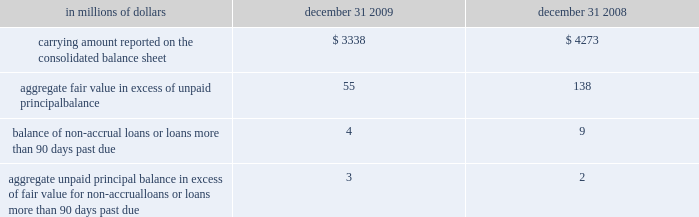Certain mortgage loans citigroup has elected the fair value option for certain purchased and originated prime fixed-rate and conforming adjustable-rate first mortgage loans held-for-sale .
These loans are intended for sale or securitization and are hedged with derivative instruments .
The company has elected the fair value option to mitigate accounting mismatches in cases where hedge .
The changes in fair values of these mortgage loans are reported in other revenue in the company 2019s consolidated statement of income .
The changes in fair value during the years ended december 31 , 2009 and 2008 due to instrument-specific credit risk resulted in a $ 10 million loss and $ 32 million loss , respectively .
Related interest income continues to be measured based on the contractual interest rates and reported as such in the consolidated statement of income .
Mortgage servicing rights the company accounts for mortgage servicing rights ( msrs ) at fair value .
Fair value for msrs is determined using an option-adjusted spread valuation approach .
This approach consists of projecting servicing cash flows under multiple interest-rate scenarios and discounting these cash flows using risk-adjusted rates .
The model assumptions used in the valuation of msrs include mortgage prepayment speeds and discount rates .
The fair value of msrs is primarily affected by changes in prepayments that result from shifts in mortgage interest rates .
In managing this risk , the company hedges a significant portion of the values of its msrs through the use of interest-rate derivative contracts , forward-purchase commitments of mortgage-backed securities , and purchased securities classified as trading .
See note 23 to the consolidated financial statements for further discussions regarding the accounting and reporting of msrs .
These msrs , which totaled $ 6.5 billion and $ 5.7 billion as of december 31 , 2009 and 2008 , respectively , are classified as mortgage servicing rights on citigroup 2019s consolidated balance sheet .
Changes in fair value of msrs are recorded in commissions and fees in the company 2019s consolidated statement of income .
Certain structured liabilities the company has elected the fair value option for certain structured liabilities whose performance is linked to structured interest rates , inflation or currency risks ( 201cstructured liabilities 201d ) .
The company elected the fair value option , because these exposures are considered to be trading-related positions and , therefore , are managed on a fair value basis .
These positions will continue to be classified as debt , deposits or derivatives ( trading account liabilities ) on the company 2019s consolidated balance sheet according to their legal form .
For those structured liabilities classified as long-term debt for which the fair value option has been elected , the aggregate unpaid principal balance exceeded the aggregate fair value by $ 125 million and $ 671 million as of december 31 , 2009 and 2008 , respectively .
The change in fair value for these structured liabilities is reported in principal transactions in the company 2019s consolidated statement of income .
Related interest expense is measured based on the contractual interest rates and reported as such in the consolidated income statement .
Certain non-structured liabilities the company has elected the fair value option for certain non-structured liabilities with fixed and floating interest rates ( 201cnon-structured liabilities 201d ) .
The company has elected the fair value option where the interest-rate risk of such liabilities is economically hedged with derivative contracts or the proceeds are used to purchase financial assets that will also be accounted for at fair value through earnings .
The election has been made to mitigate accounting mismatches and to achieve operational simplifications .
These positions are reported in short-term borrowings and long-term debt on the company 2019s consolidated balance sheet .
For those non-structured liabilities classified as short-term borrowings for which the fair value option has been elected , the aggregate unpaid principal balance exceeded the aggregate fair value of such instruments by $ 220 million as of december 31 , 2008 .
For non-structured liabilities classified as long-term debt for which the fair value option has been elected , the aggregate unpaid principal balance exceeded the aggregate fair value by $ 1542 million and $ 856 million as of december 31 , 2009 and 2008 , respectively .
The change in fair value for these non-structured liabilities is reported in principal transactions in the company 2019s consolidated statement of income .
Related interest expense continues to be measured based on the contractual interest rates and reported as such in the consolidated income statement .
Accounting is complex and to achieve operational simplifications .
The fair value option was not elected for loans held-for-investment , as those loans are not hedged with derivative instruments .
The following table provides information about certain mortgage loans carried at fair value: .
What was the percentage decline in aggregate fair value in excess of unpaid principal balance for the loans accounted for with the fair value option from 2008 to 2009? 
Computations: ((55 - 138) / 138)
Answer: -0.60145. 